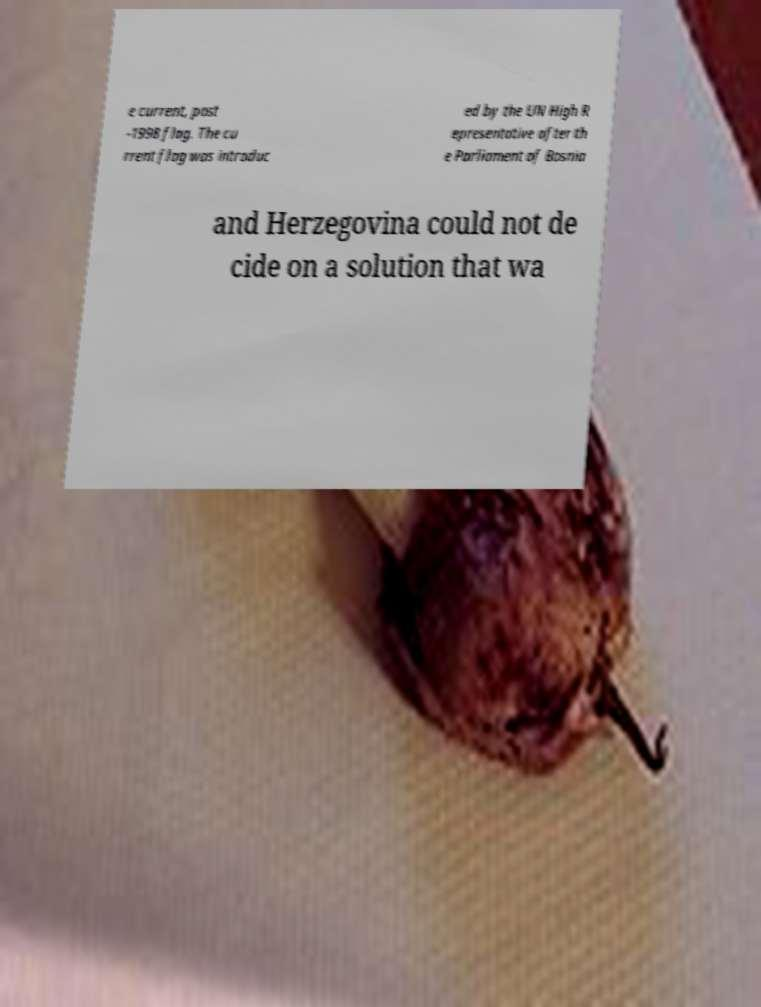Can you accurately transcribe the text from the provided image for me? e current, post -1998 flag. The cu rrent flag was introduc ed by the UN High R epresentative after th e Parliament of Bosnia and Herzegovina could not de cide on a solution that wa 